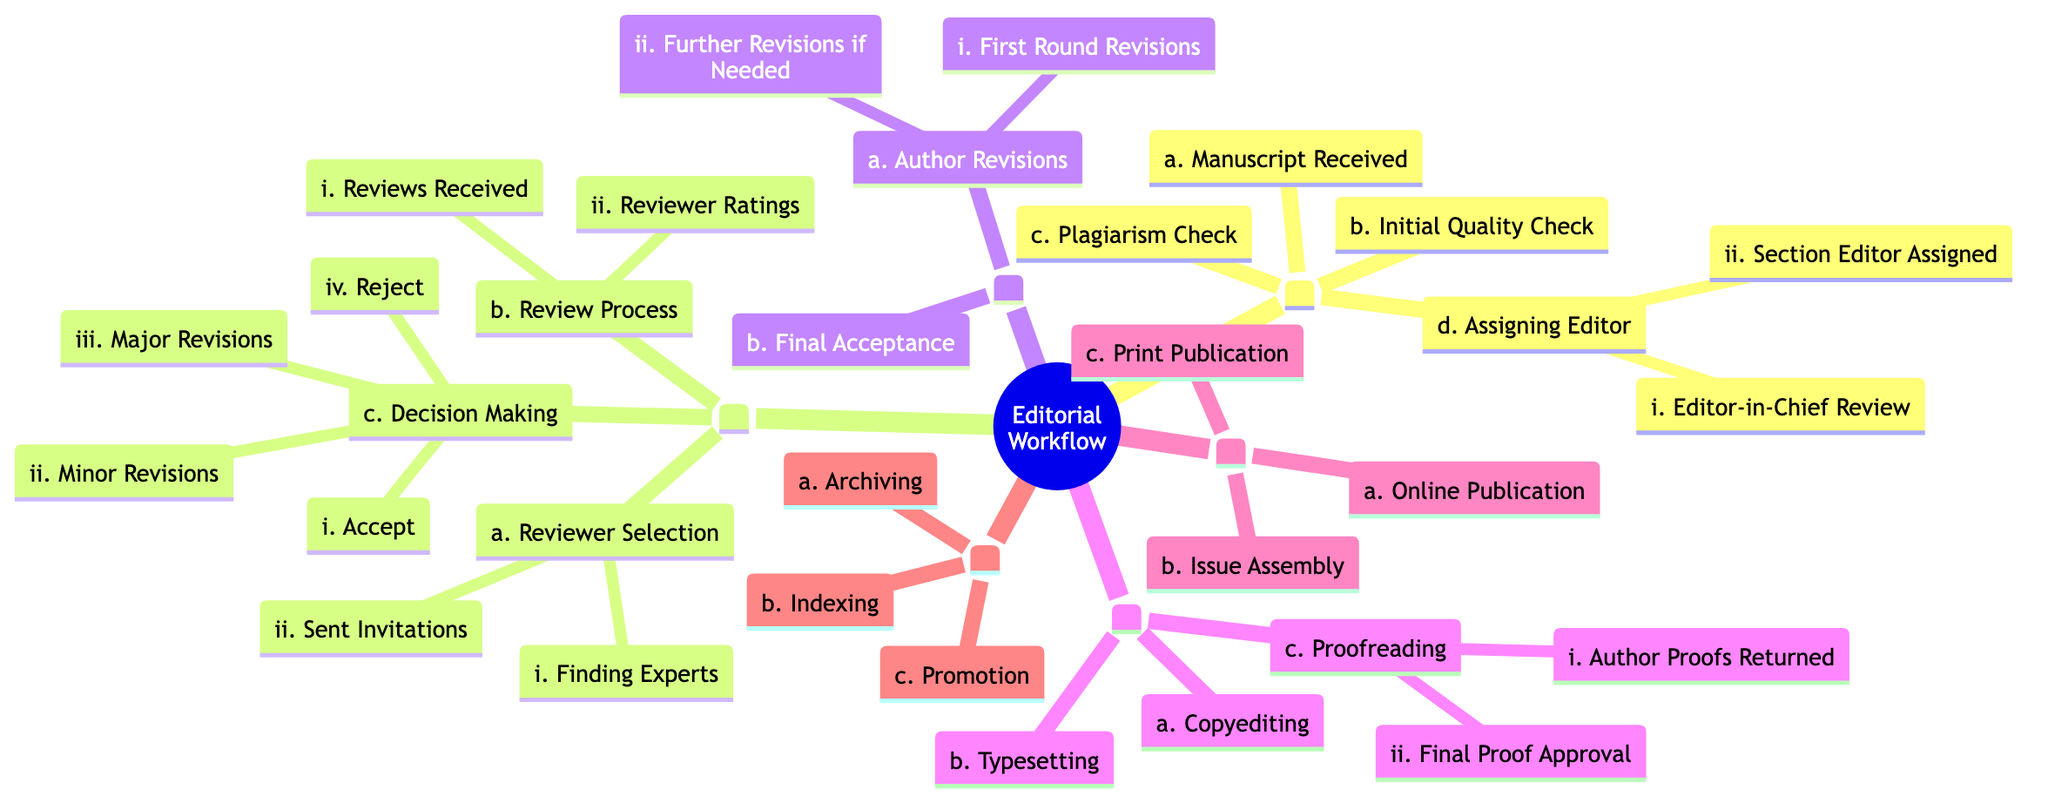What is the first step in the editorial workflow? The first step in the workflow is "Submission," which is the main branch that outlines the beginning of the editorial process.
Answer: Submission How many sub-elements does the "Assigning Editor" node have? The "Assigning Editor" node has two sub-elements: "Editor-in-Chief Review" and "Section Editor Assigned." Thus, there are a total of two sub-elements.
Answer: 2 Which decision options are available in the "Decision Making" process? The "Decision Making" process has four options: "Accept," "Minor Revisions," "Major Revisions," and "Reject," which indicate different outcomes for the manuscript after review.
Answer: Accept, Minor Revisions, Major Revisions, Reject What follows after "Author Revisions" in the workflow? After "Author Revisions," the next step is "Final Acceptance," which signifies the approval of the manuscript after necessary revisions have been made by the authors.
Answer: Final Acceptance In which section do we find "Typesetting"? "Typesetting" is found in the "Production" section, which includes various tasks needed to prepare the document for publication.
Answer: Production How many main branches are there in the editorial workflow? The editorial workflow consists of six main branches: "Submission," "Peer Review," "Revision and Acceptance," "Production," "Publication," and "Post-Publication." Therefore, the total number of main branches is six.
Answer: 6 What is the last step mentioned in the workflow before publication? The last step mentioned in the workflow before publication is "Final Proof Approval," which occurs during the "Proofreading" phase of the "Production" section.
Answer: Final Proof Approval Which branch contains the "Plagiarism Check"? The "Plagiarism Check" is part of the "Submission" branch. This step involves verifying the originality of the manuscript before it proceeds further in the workflow.
Answer: Submission How many elements are in the "Review Process"? The "Review Process" includes two elements: "Reviews Received" and "Reviewer Ratings." Thus, there are two elements in total for this phase.
Answer: 2 